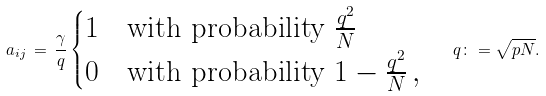Convert formula to latex. <formula><loc_0><loc_0><loc_500><loc_500>a _ { i j } \, = \, \frac { \gamma } { q } \begin{cases} 1 & \text {with probability } \frac { q ^ { 2 } } { N } \\ 0 & \text {with probability } 1 - \frac { q ^ { 2 } } { N } \, , \end{cases} \quad q \colon = \sqrt { p N } .</formula> 